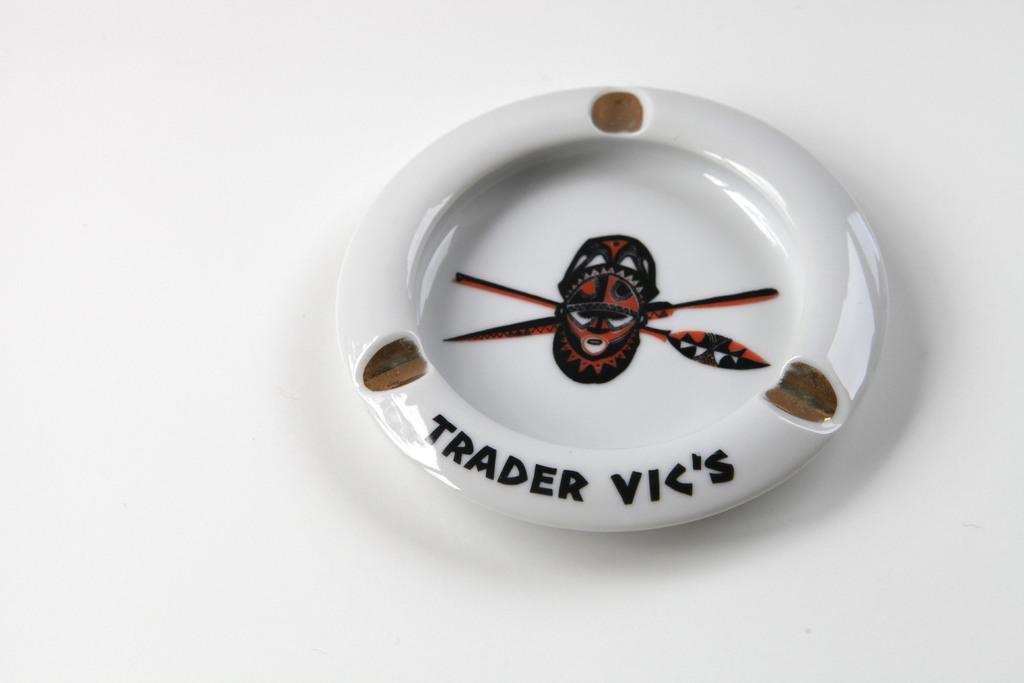Can you describe this image briefly? In this image there is a plate. There is text on the plate. In the center there is picture art. The background is white. 